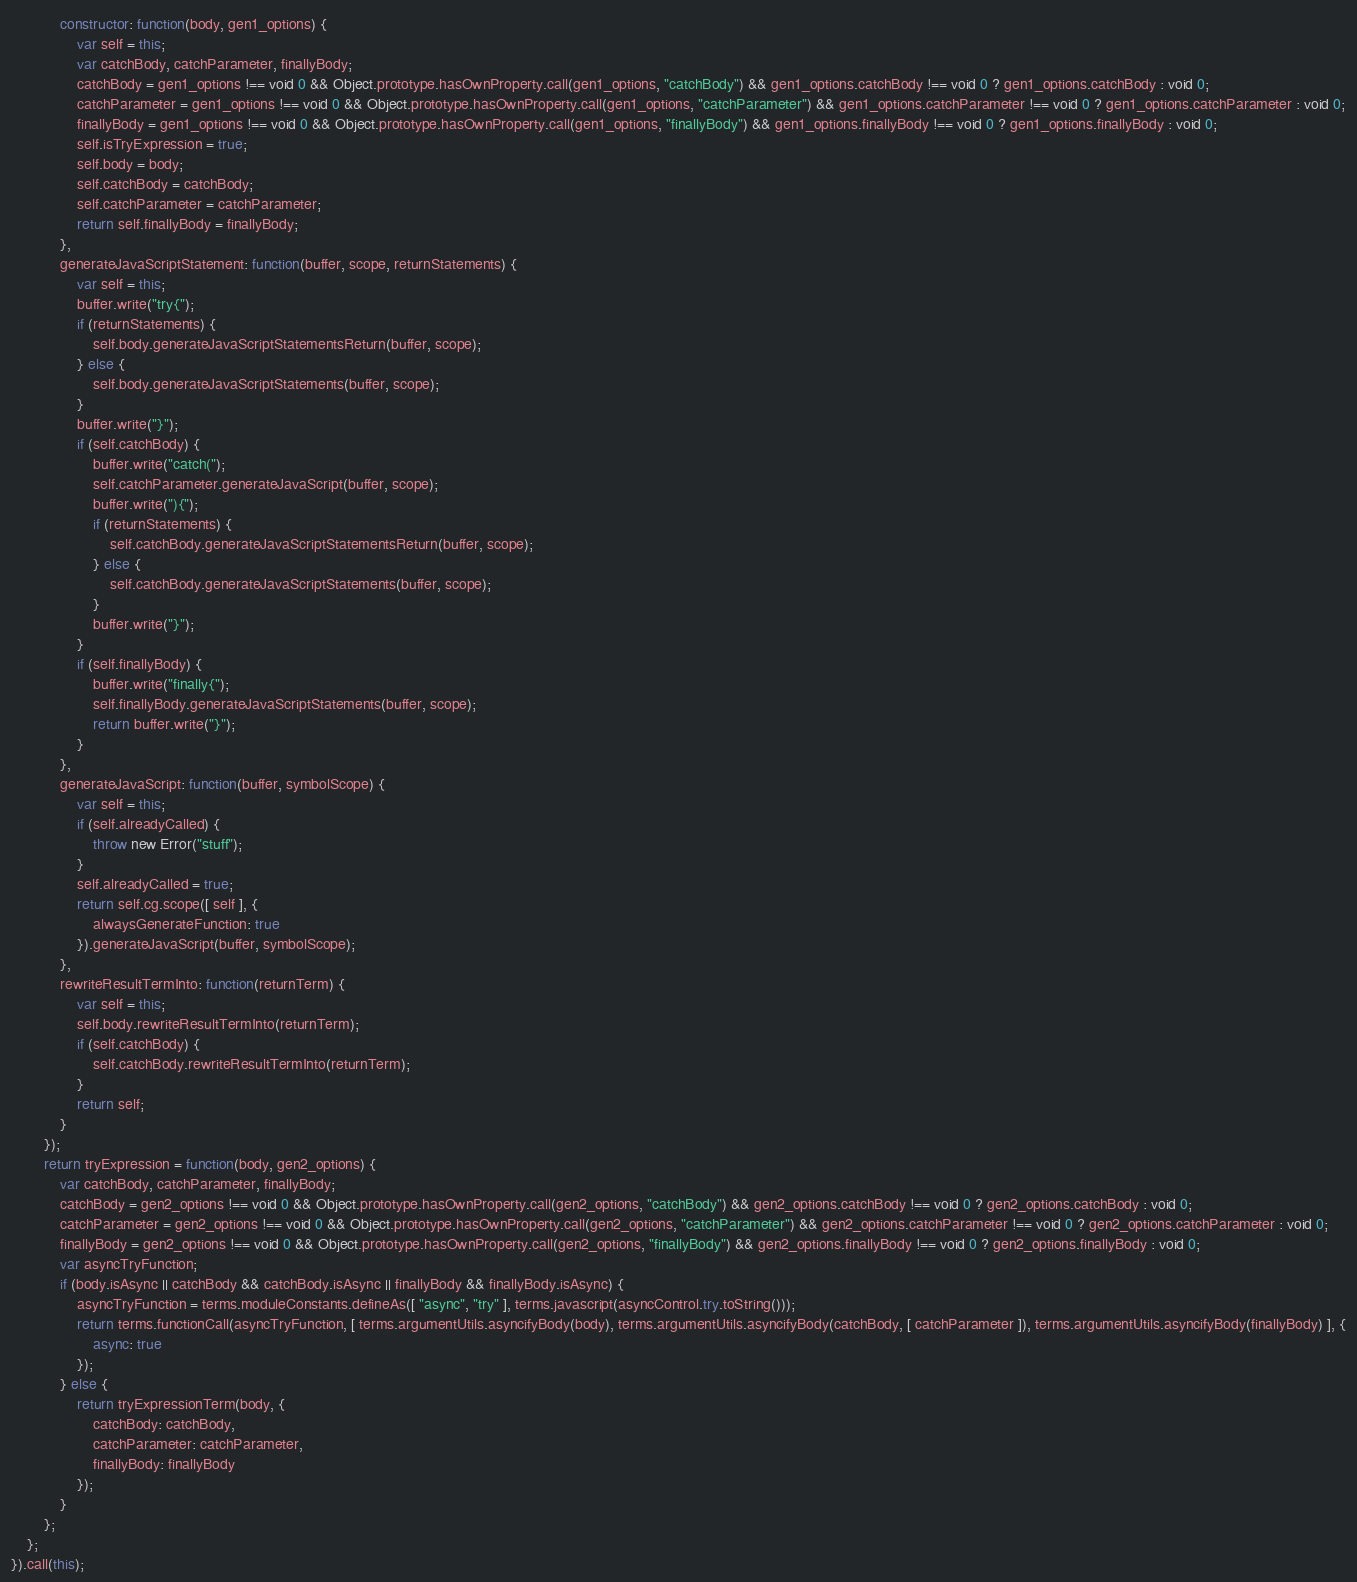Convert code to text. <code><loc_0><loc_0><loc_500><loc_500><_JavaScript_>            constructor: function(body, gen1_options) {
                var self = this;
                var catchBody, catchParameter, finallyBody;
                catchBody = gen1_options !== void 0 && Object.prototype.hasOwnProperty.call(gen1_options, "catchBody") && gen1_options.catchBody !== void 0 ? gen1_options.catchBody : void 0;
                catchParameter = gen1_options !== void 0 && Object.prototype.hasOwnProperty.call(gen1_options, "catchParameter") && gen1_options.catchParameter !== void 0 ? gen1_options.catchParameter : void 0;
                finallyBody = gen1_options !== void 0 && Object.prototype.hasOwnProperty.call(gen1_options, "finallyBody") && gen1_options.finallyBody !== void 0 ? gen1_options.finallyBody : void 0;
                self.isTryExpression = true;
                self.body = body;
                self.catchBody = catchBody;
                self.catchParameter = catchParameter;
                return self.finallyBody = finallyBody;
            },
            generateJavaScriptStatement: function(buffer, scope, returnStatements) {
                var self = this;
                buffer.write("try{");
                if (returnStatements) {
                    self.body.generateJavaScriptStatementsReturn(buffer, scope);
                } else {
                    self.body.generateJavaScriptStatements(buffer, scope);
                }
                buffer.write("}");
                if (self.catchBody) {
                    buffer.write("catch(");
                    self.catchParameter.generateJavaScript(buffer, scope);
                    buffer.write("){");
                    if (returnStatements) {
                        self.catchBody.generateJavaScriptStatementsReturn(buffer, scope);
                    } else {
                        self.catchBody.generateJavaScriptStatements(buffer, scope);
                    }
                    buffer.write("}");
                }
                if (self.finallyBody) {
                    buffer.write("finally{");
                    self.finallyBody.generateJavaScriptStatements(buffer, scope);
                    return buffer.write("}");
                }
            },
            generateJavaScript: function(buffer, symbolScope) {
                var self = this;
                if (self.alreadyCalled) {
                    throw new Error("stuff");
                }
                self.alreadyCalled = true;
                return self.cg.scope([ self ], {
                    alwaysGenerateFunction: true
                }).generateJavaScript(buffer, symbolScope);
            },
            rewriteResultTermInto: function(returnTerm) {
                var self = this;
                self.body.rewriteResultTermInto(returnTerm);
                if (self.catchBody) {
                    self.catchBody.rewriteResultTermInto(returnTerm);
                }
                return self;
            }
        });
        return tryExpression = function(body, gen2_options) {
            var catchBody, catchParameter, finallyBody;
            catchBody = gen2_options !== void 0 && Object.prototype.hasOwnProperty.call(gen2_options, "catchBody") && gen2_options.catchBody !== void 0 ? gen2_options.catchBody : void 0;
            catchParameter = gen2_options !== void 0 && Object.prototype.hasOwnProperty.call(gen2_options, "catchParameter") && gen2_options.catchParameter !== void 0 ? gen2_options.catchParameter : void 0;
            finallyBody = gen2_options !== void 0 && Object.prototype.hasOwnProperty.call(gen2_options, "finallyBody") && gen2_options.finallyBody !== void 0 ? gen2_options.finallyBody : void 0;
            var asyncTryFunction;
            if (body.isAsync || catchBody && catchBody.isAsync || finallyBody && finallyBody.isAsync) {
                asyncTryFunction = terms.moduleConstants.defineAs([ "async", "try" ], terms.javascript(asyncControl.try.toString()));
                return terms.functionCall(asyncTryFunction, [ terms.argumentUtils.asyncifyBody(body), terms.argumentUtils.asyncifyBody(catchBody, [ catchParameter ]), terms.argumentUtils.asyncifyBody(finallyBody) ], {
                    async: true
                });
            } else {
                return tryExpressionTerm(body, {
                    catchBody: catchBody,
                    catchParameter: catchParameter,
                    finallyBody: finallyBody
                });
            }
        };
    };
}).call(this);</code> 